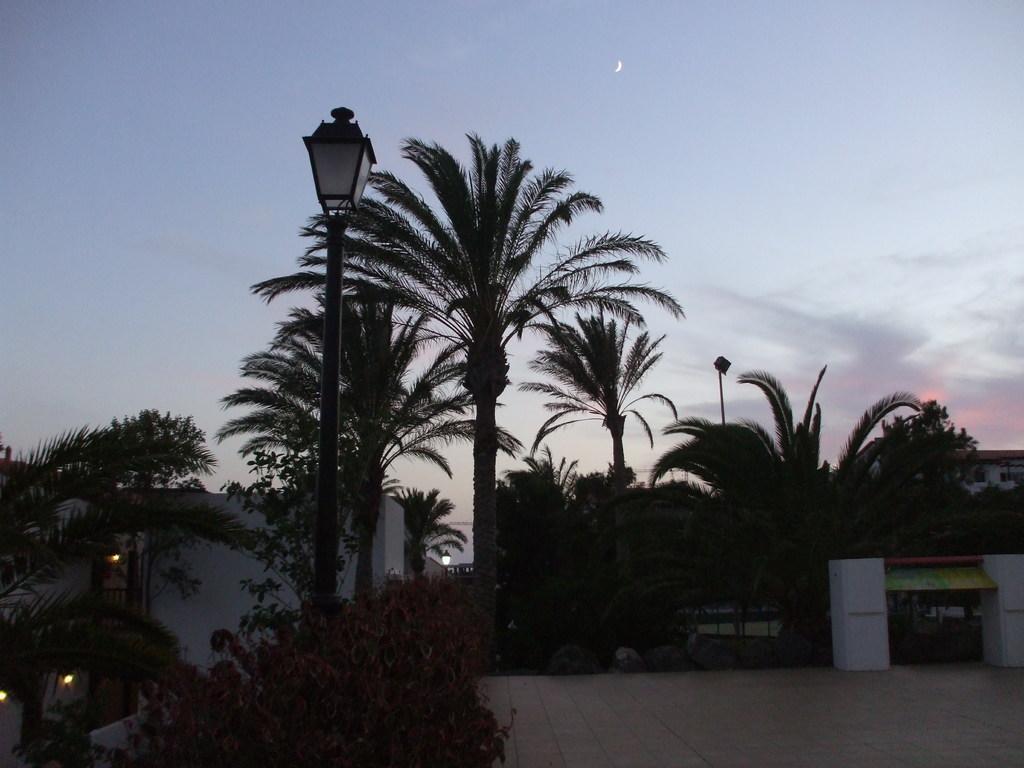Can you describe this image briefly? In this image we can see plants, trees, poles, lights, floor, pillars, and houses. In the background there is sky with clouds. 